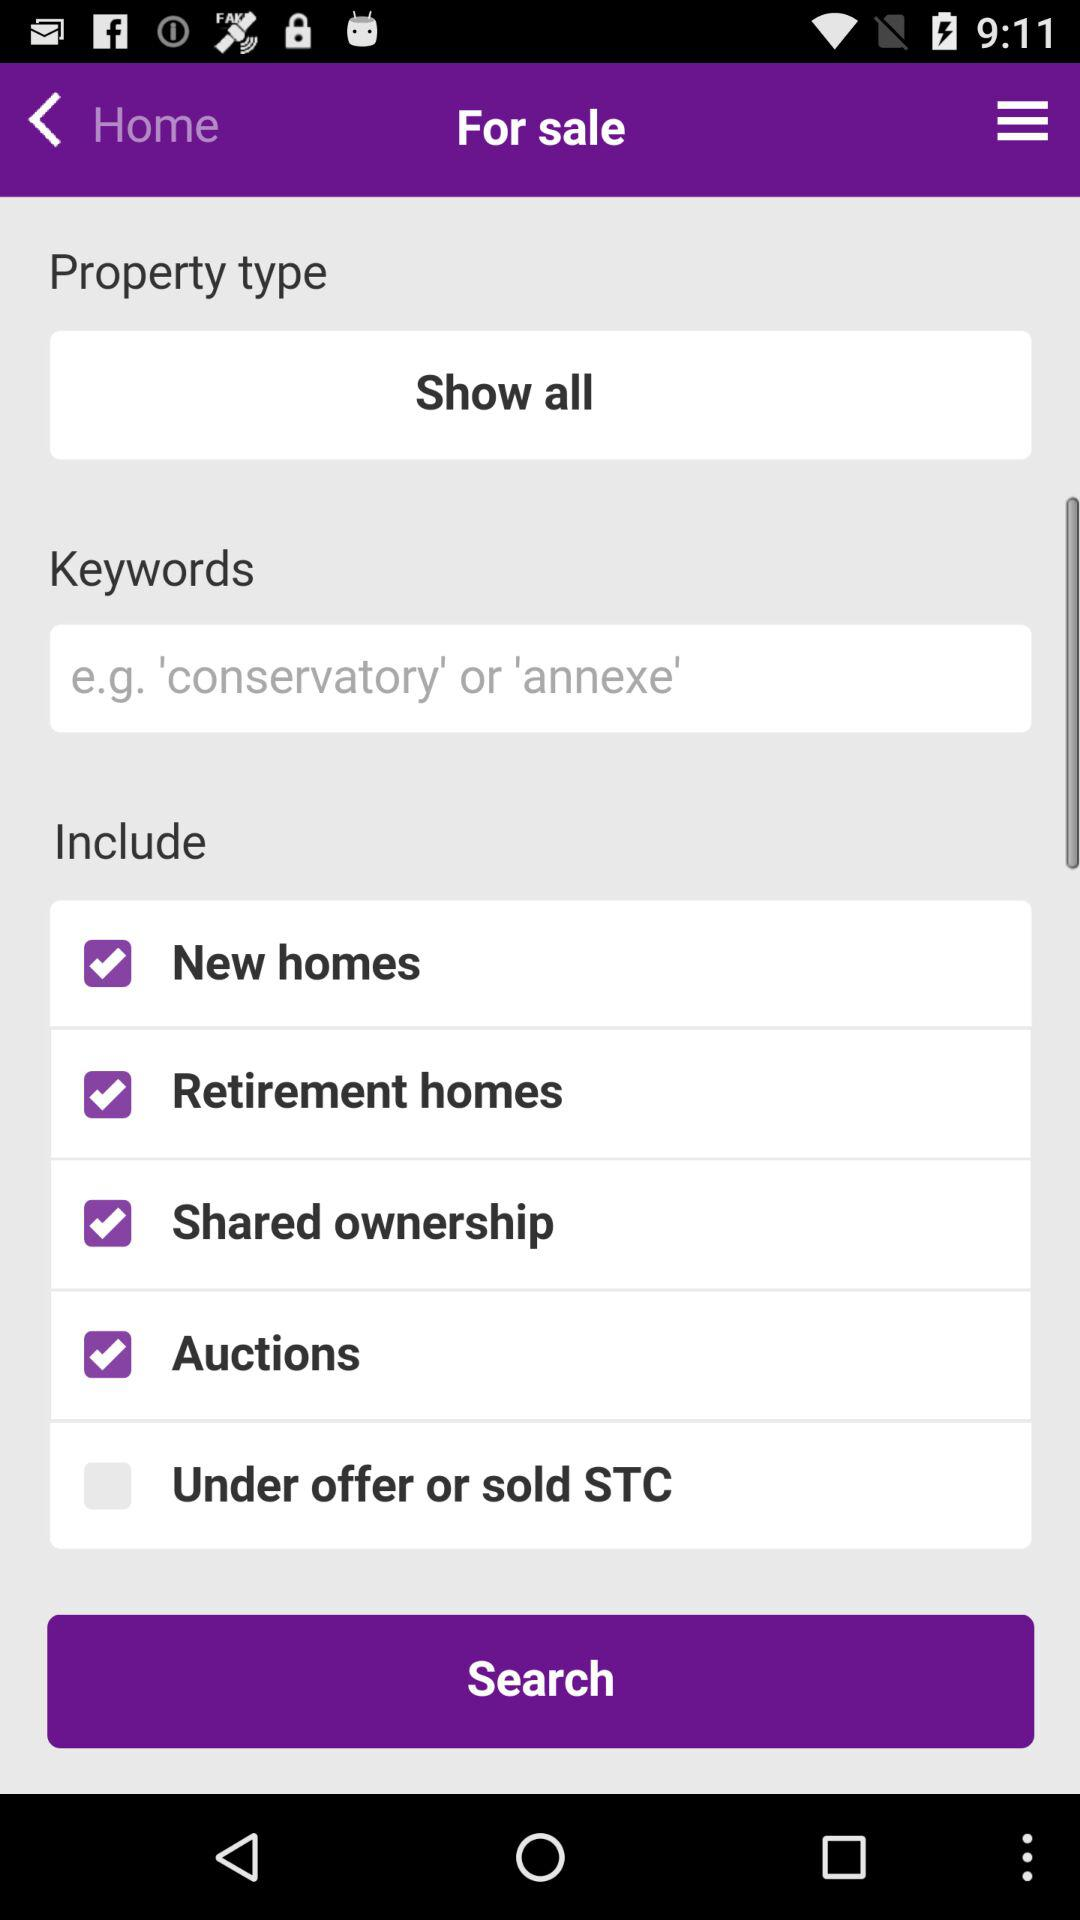What is the selected "Property type"? The selected "Property type" is "Show all". 